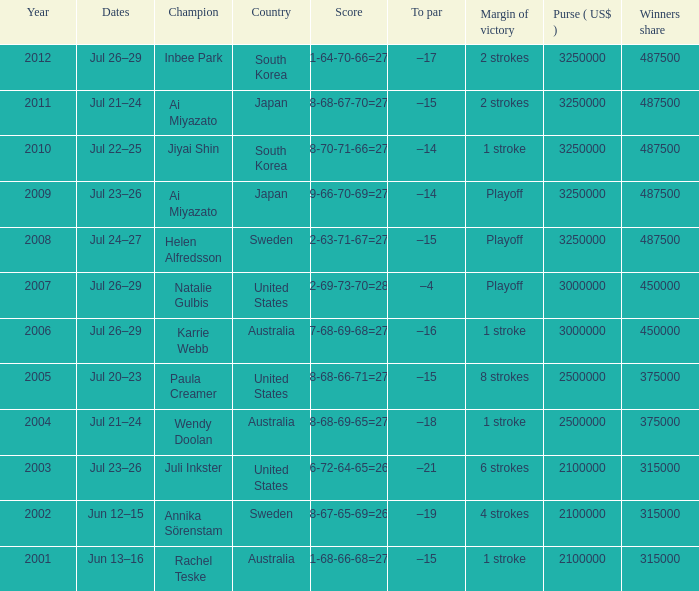What countries have a margin of victory at 6 strokes? United States. 